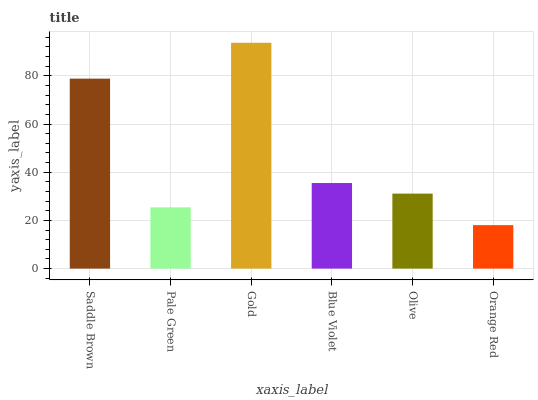Is Orange Red the minimum?
Answer yes or no. Yes. Is Gold the maximum?
Answer yes or no. Yes. Is Pale Green the minimum?
Answer yes or no. No. Is Pale Green the maximum?
Answer yes or no. No. Is Saddle Brown greater than Pale Green?
Answer yes or no. Yes. Is Pale Green less than Saddle Brown?
Answer yes or no. Yes. Is Pale Green greater than Saddle Brown?
Answer yes or no. No. Is Saddle Brown less than Pale Green?
Answer yes or no. No. Is Blue Violet the high median?
Answer yes or no. Yes. Is Olive the low median?
Answer yes or no. Yes. Is Saddle Brown the high median?
Answer yes or no. No. Is Saddle Brown the low median?
Answer yes or no. No. 